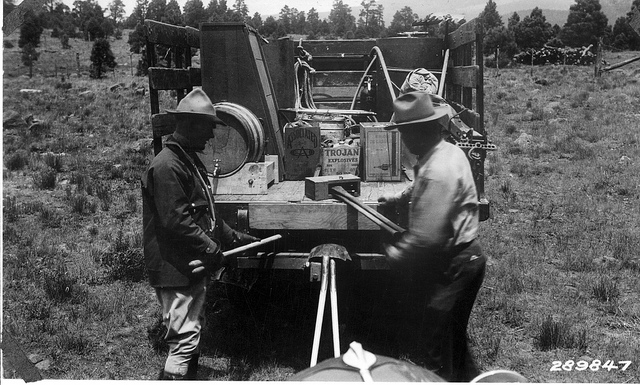Please identify all text content in this image. TROJAN 289847 